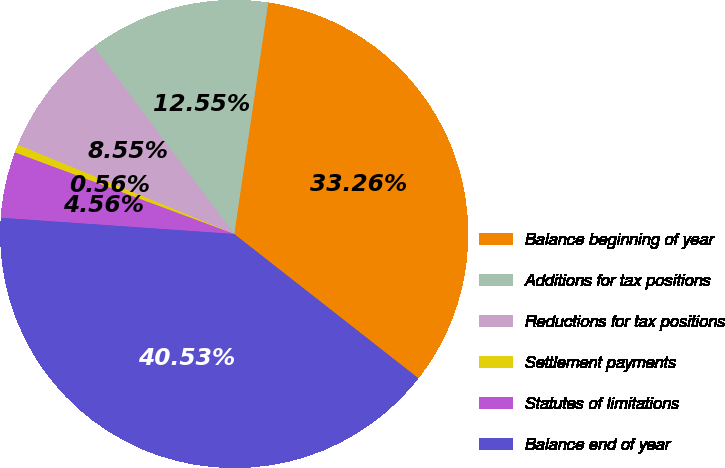Convert chart. <chart><loc_0><loc_0><loc_500><loc_500><pie_chart><fcel>Balance beginning of year<fcel>Additions for tax positions<fcel>Reductions for tax positions<fcel>Settlement payments<fcel>Statutes of limitations<fcel>Balance end of year<nl><fcel>33.26%<fcel>12.55%<fcel>8.55%<fcel>0.56%<fcel>4.56%<fcel>40.53%<nl></chart> 